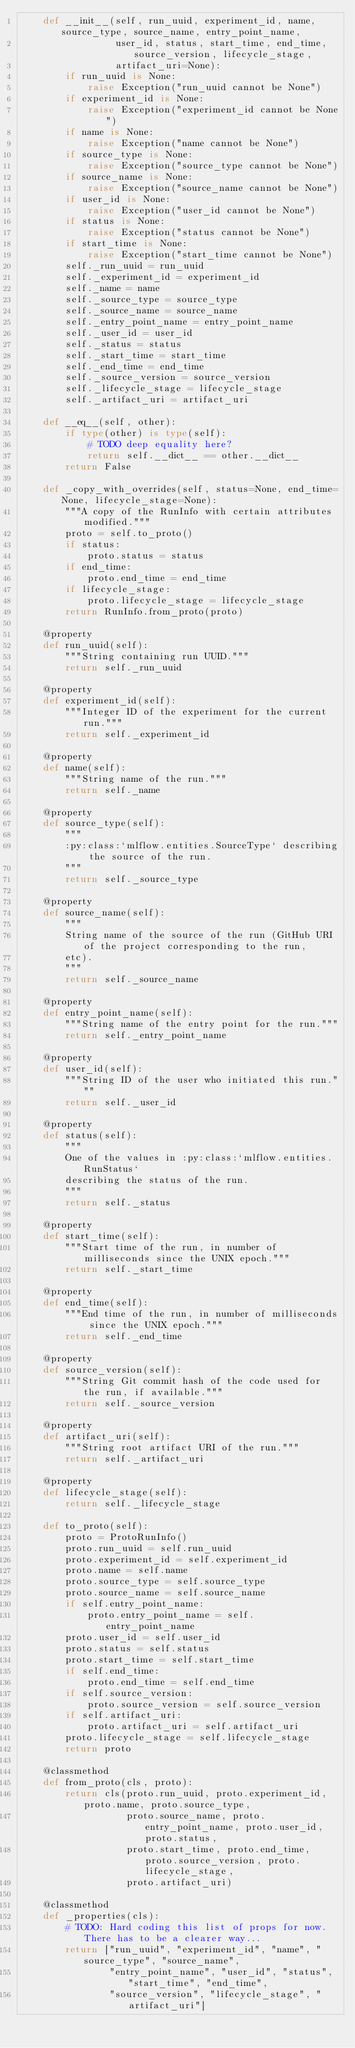Convert code to text. <code><loc_0><loc_0><loc_500><loc_500><_Python_>    def __init__(self, run_uuid, experiment_id, name, source_type, source_name, entry_point_name,
                 user_id, status, start_time, end_time, source_version, lifecycle_stage,
                 artifact_uri=None):
        if run_uuid is None:
            raise Exception("run_uuid cannot be None")
        if experiment_id is None:
            raise Exception("experiment_id cannot be None")
        if name is None:
            raise Exception("name cannot be None")
        if source_type is None:
            raise Exception("source_type cannot be None")
        if source_name is None:
            raise Exception("source_name cannot be None")
        if user_id is None:
            raise Exception("user_id cannot be None")
        if status is None:
            raise Exception("status cannot be None")
        if start_time is None:
            raise Exception("start_time cannot be None")
        self._run_uuid = run_uuid
        self._experiment_id = experiment_id
        self._name = name
        self._source_type = source_type
        self._source_name = source_name
        self._entry_point_name = entry_point_name
        self._user_id = user_id
        self._status = status
        self._start_time = start_time
        self._end_time = end_time
        self._source_version = source_version
        self._lifecycle_stage = lifecycle_stage
        self._artifact_uri = artifact_uri

    def __eq__(self, other):
        if type(other) is type(self):
            # TODO deep equality here?
            return self.__dict__ == other.__dict__
        return False

    def _copy_with_overrides(self, status=None, end_time=None, lifecycle_stage=None):
        """A copy of the RunInfo with certain attributes modified."""
        proto = self.to_proto()
        if status:
            proto.status = status
        if end_time:
            proto.end_time = end_time
        if lifecycle_stage:
            proto.lifecycle_stage = lifecycle_stage
        return RunInfo.from_proto(proto)

    @property
    def run_uuid(self):
        """String containing run UUID."""
        return self._run_uuid

    @property
    def experiment_id(self):
        """Integer ID of the experiment for the current run."""
        return self._experiment_id

    @property
    def name(self):
        """String name of the run."""
        return self._name

    @property
    def source_type(self):
        """
        :py:class:`mlflow.entities.SourceType` describing the source of the run.
        """
        return self._source_type

    @property
    def source_name(self):
        """
        String name of the source of the run (GitHub URI of the project corresponding to the run,
        etc).
        """
        return self._source_name

    @property
    def entry_point_name(self):
        """String name of the entry point for the run."""
        return self._entry_point_name

    @property
    def user_id(self):
        """String ID of the user who initiated this run."""
        return self._user_id

    @property
    def status(self):
        """
        One of the values in :py:class:`mlflow.entities.RunStatus`
        describing the status of the run.
        """
        return self._status

    @property
    def start_time(self):
        """Start time of the run, in number of milliseconds since the UNIX epoch."""
        return self._start_time

    @property
    def end_time(self):
        """End time of the run, in number of milliseconds since the UNIX epoch."""
        return self._end_time

    @property
    def source_version(self):
        """String Git commit hash of the code used for the run, if available."""
        return self._source_version

    @property
    def artifact_uri(self):
        """String root artifact URI of the run."""
        return self._artifact_uri

    @property
    def lifecycle_stage(self):
        return self._lifecycle_stage

    def to_proto(self):
        proto = ProtoRunInfo()
        proto.run_uuid = self.run_uuid
        proto.experiment_id = self.experiment_id
        proto.name = self.name
        proto.source_type = self.source_type
        proto.source_name = self.source_name
        if self.entry_point_name:
            proto.entry_point_name = self.entry_point_name
        proto.user_id = self.user_id
        proto.status = self.status
        proto.start_time = self.start_time
        if self.end_time:
            proto.end_time = self.end_time
        if self.source_version:
            proto.source_version = self.source_version
        if self.artifact_uri:
            proto.artifact_uri = self.artifact_uri
        proto.lifecycle_stage = self.lifecycle_stage
        return proto

    @classmethod
    def from_proto(cls, proto):
        return cls(proto.run_uuid, proto.experiment_id, proto.name, proto.source_type,
                   proto.source_name, proto.entry_point_name, proto.user_id, proto.status,
                   proto.start_time, proto.end_time, proto.source_version, proto.lifecycle_stage,
                   proto.artifact_uri)

    @classmethod
    def _properties(cls):
        # TODO: Hard coding this list of props for now. There has to be a clearer way...
        return ["run_uuid", "experiment_id", "name", "source_type", "source_name",
                "entry_point_name", "user_id", "status", "start_time", "end_time",
                "source_version", "lifecycle_stage", "artifact_uri"]
</code> 